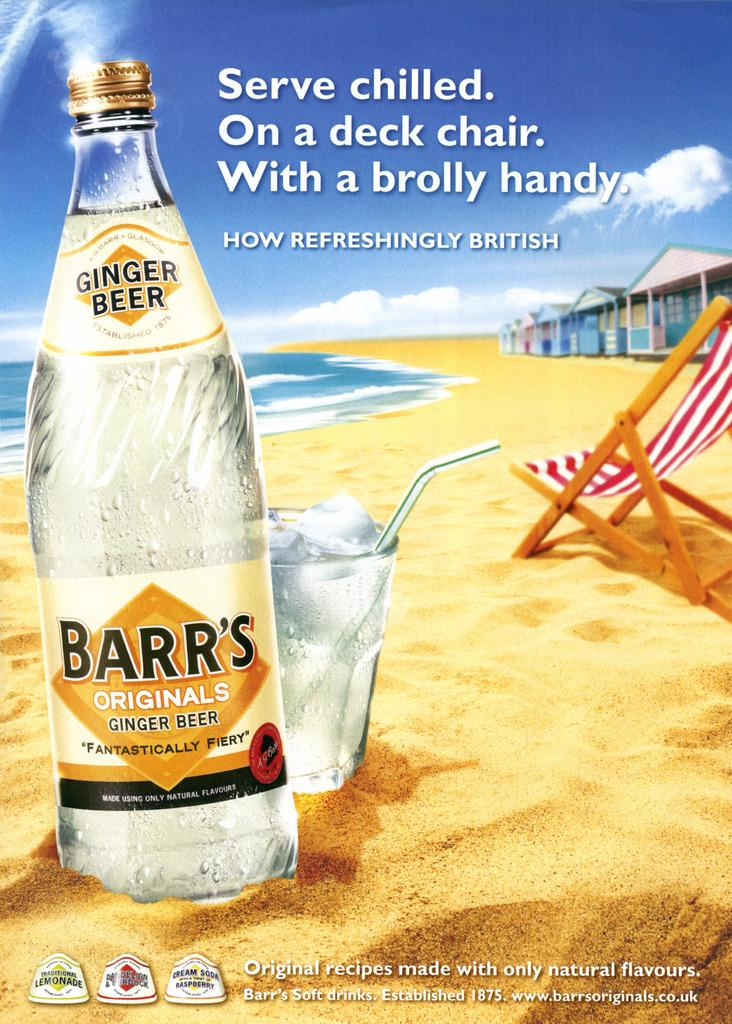<image>
Write a terse but informative summary of the picture. A bottle of Barr's ginger beer is in the sand near a beach. 